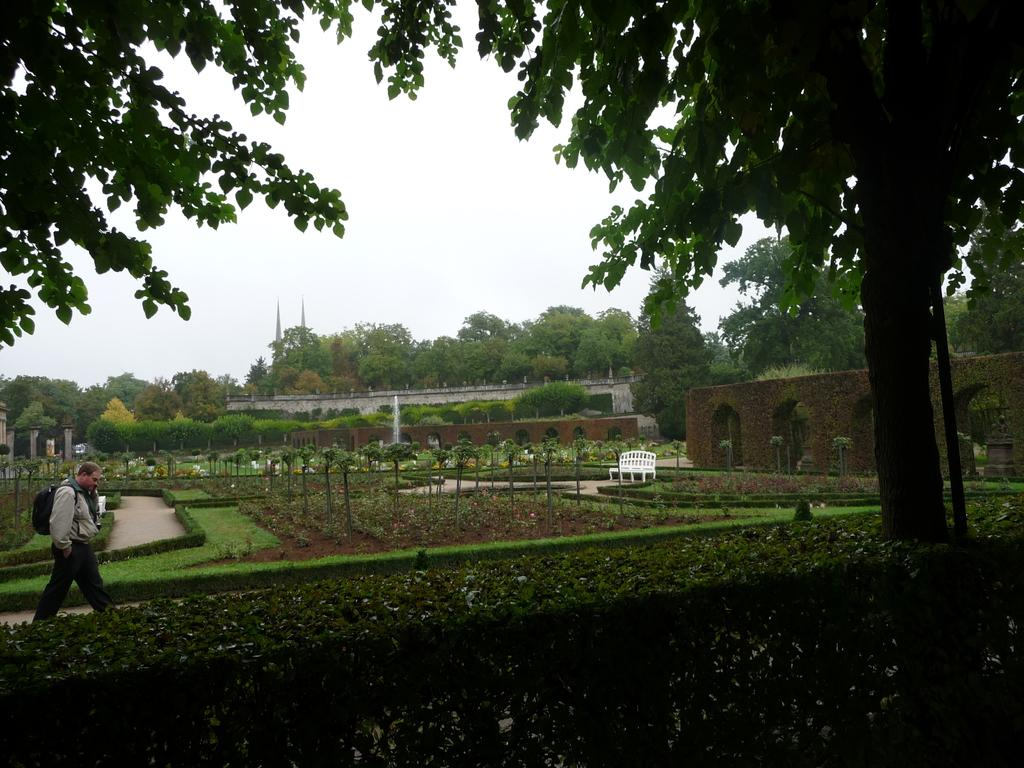What can be seen in the image? There is a person in the image. Can you describe the person's attire? The person is wearing clothes. What is the person carrying on his back? The person is carrying a bag on his back. What type of natural elements are present in the image? There are trees and plants in the image. What type of structure is visible in the image? There is a fort in the image. What is the color of the sky in the image? The sky is white in the image. What type of cork can be seen in the person's hand in the image? There is no cork present in the image. What type of mitten is the person wearing on their feet in the image? The person is not wearing any mittens in the image; they are wearing shoes or other footwear. 